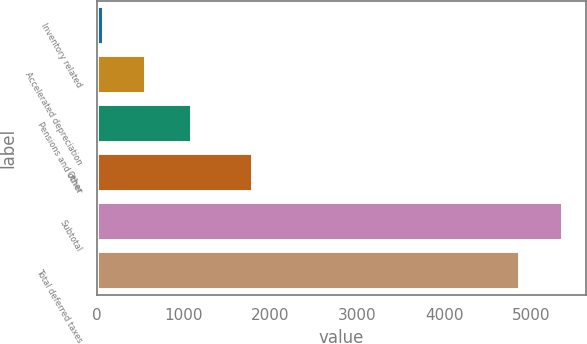Convert chart. <chart><loc_0><loc_0><loc_500><loc_500><bar_chart><fcel>Inventory related<fcel>Accelerated depreciation<fcel>Pensions and other<fcel>Other<fcel>Subtotal<fcel>Total deferred taxes<nl><fcel>79<fcel>569.4<fcel>1098<fcel>1798<fcel>5366.4<fcel>4876<nl></chart> 